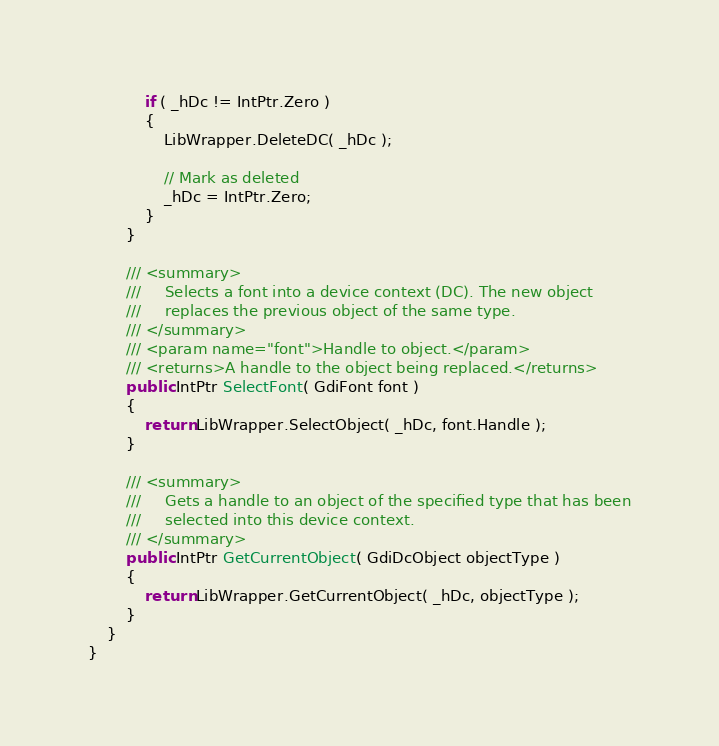Convert code to text. <code><loc_0><loc_0><loc_500><loc_500><_C#_>            if ( _hDc != IntPtr.Zero )
            {
                LibWrapper.DeleteDC( _hDc );

                // Mark as deleted
                _hDc = IntPtr.Zero;
            }
        }

        /// <summary>
        ///     Selects a font into a device context (DC). The new object
        ///     replaces the previous object of the same type.
        /// </summary>
        /// <param name="font">Handle to object.</param>
        /// <returns>A handle to the object being replaced.</returns>
        public IntPtr SelectFont( GdiFont font )
        {
            return LibWrapper.SelectObject( _hDc, font.Handle );
        }

        /// <summary>
        ///     Gets a handle to an object of the specified type that has been
        ///     selected into this device context.
        /// </summary>
        public IntPtr GetCurrentObject( GdiDcObject objectType )
        {
            return LibWrapper.GetCurrentObject( _hDc, objectType );
        }
    }
}</code> 